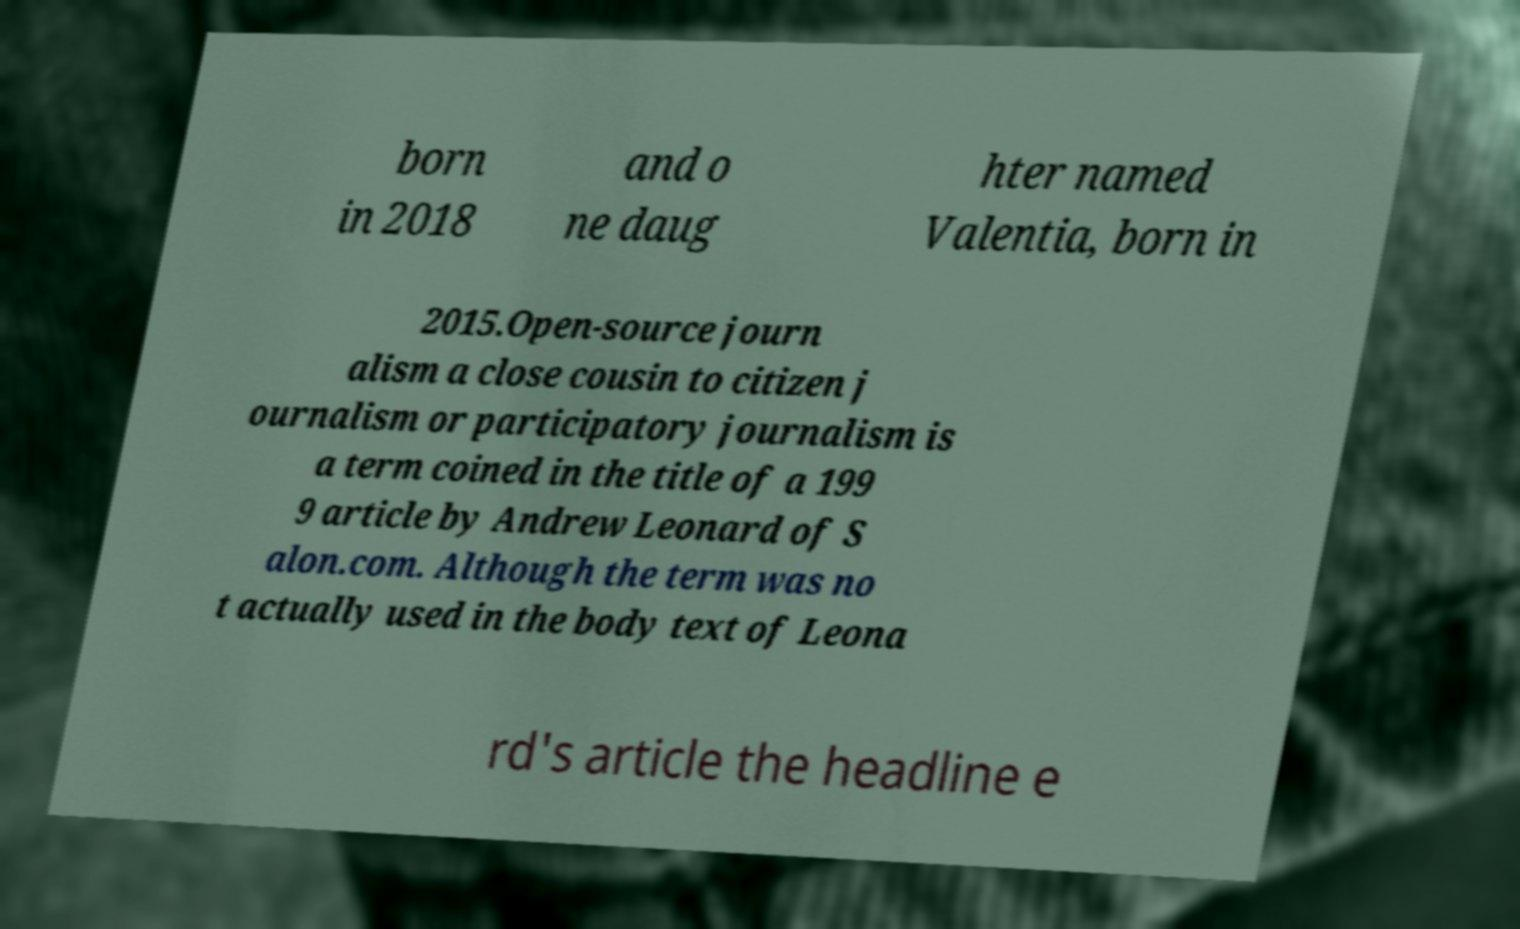Could you extract and type out the text from this image? born in 2018 and o ne daug hter named Valentia, born in 2015.Open-source journ alism a close cousin to citizen j ournalism or participatory journalism is a term coined in the title of a 199 9 article by Andrew Leonard of S alon.com. Although the term was no t actually used in the body text of Leona rd's article the headline e 